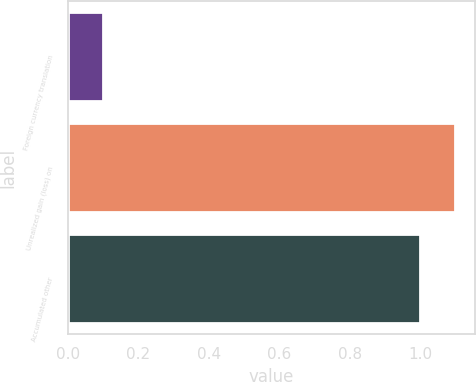Convert chart to OTSL. <chart><loc_0><loc_0><loc_500><loc_500><bar_chart><fcel>Foreign currency translation<fcel>Unrealized gain (loss) on<fcel>Accumulated other<nl><fcel>0.1<fcel>1.1<fcel>1<nl></chart> 